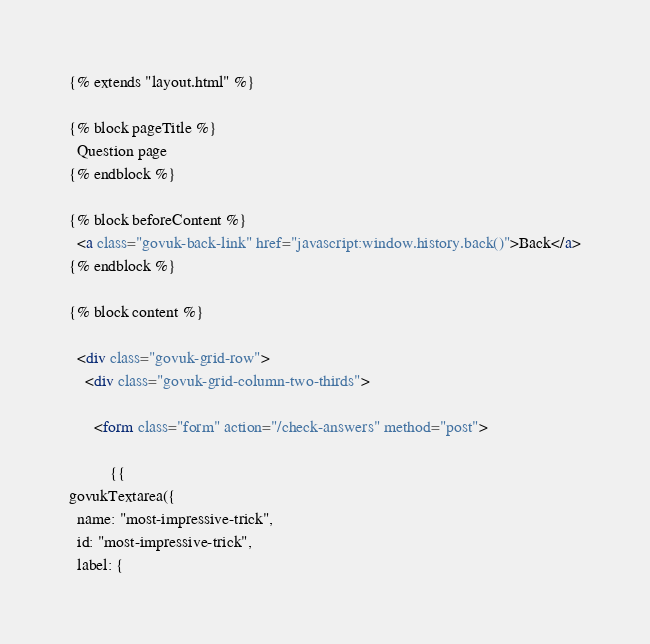<code> <loc_0><loc_0><loc_500><loc_500><_HTML_>{% extends "layout.html" %}

{% block pageTitle %}
  Question page
{% endblock %}

{% block beforeContent %}
  <a class="govuk-back-link" href="javascript:window.history.back()">Back</a>
{% endblock %}

{% block content %}

  <div class="govuk-grid-row">
    <div class="govuk-grid-column-two-thirds">

      <form class="form" action="/check-answers" method="post">

          {{
govukTextarea({
  name: "most-impressive-trick",
  id: "most-impressive-trick",
  label: {</code> 